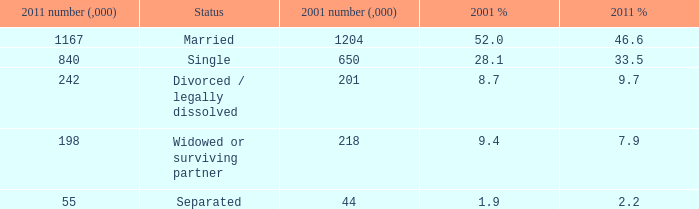What is the 2011 number (,000) when the status is separated? 55.0. 